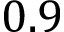<formula> <loc_0><loc_0><loc_500><loc_500>0 . 9</formula> 